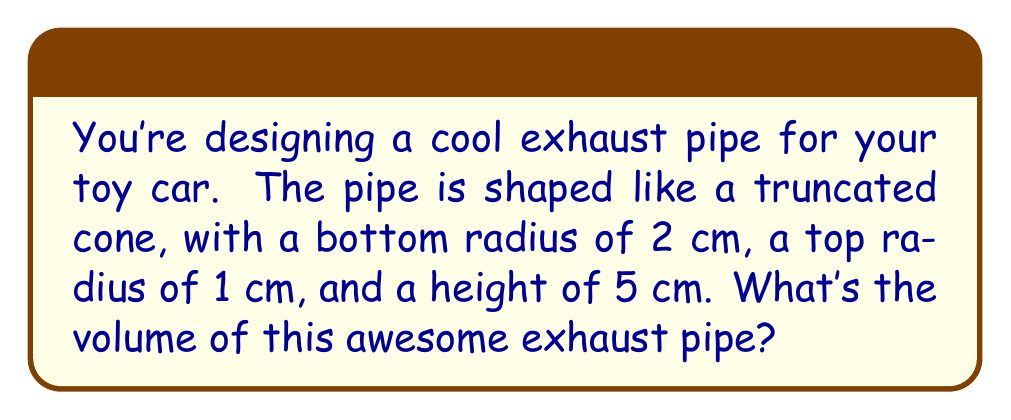Teach me how to tackle this problem. Let's break this down step-by-step:

1) The formula for the volume of a truncated cone is:

   $$V = \frac{1}{3}\pi h(R^2 + r^2 + Rr)$$

   Where:
   $V$ = volume
   $h$ = height
   $R$ = radius of the base (larger end)
   $r$ = radius of the top (smaller end)

2) We know:
   $h = 5$ cm
   $R = 2$ cm
   $r = 1$ cm

3) Let's substitute these values into our formula:

   $$V = \frac{1}{3}\pi \cdot 5(2^2 + 1^2 + 2 \cdot 1)$$

4) Now, let's solve what's inside the parentheses:
   $2^2 = 4$
   $1^2 = 1$
   $2 \cdot 1 = 2$
   $4 + 1 + 2 = 7$

   $$V = \frac{1}{3}\pi \cdot 5 \cdot 7$$

5) Simplify:
   $$V = \frac{35\pi}{3} \approx 36.65 \text{ cm}^3$$

[asy]
import geometry;

size(100);
real r1=2, r2=1, h=5;
path p=((0,0)--(r1,0)--(r2,h)--(0,h)--cycle);
draw(p);
draw((0,0)--(0,h));
draw((r1,0)--(r2,h));
label("5 cm",(-0.5,h/2),W);
label("2 cm",(r1/2,0),S);
label("1 cm",(r2/2,h),N);
[/asy]
Answer: $\frac{35\pi}{3} \text{ cm}^3$ or approximately $36.65 \text{ cm}^3$ 